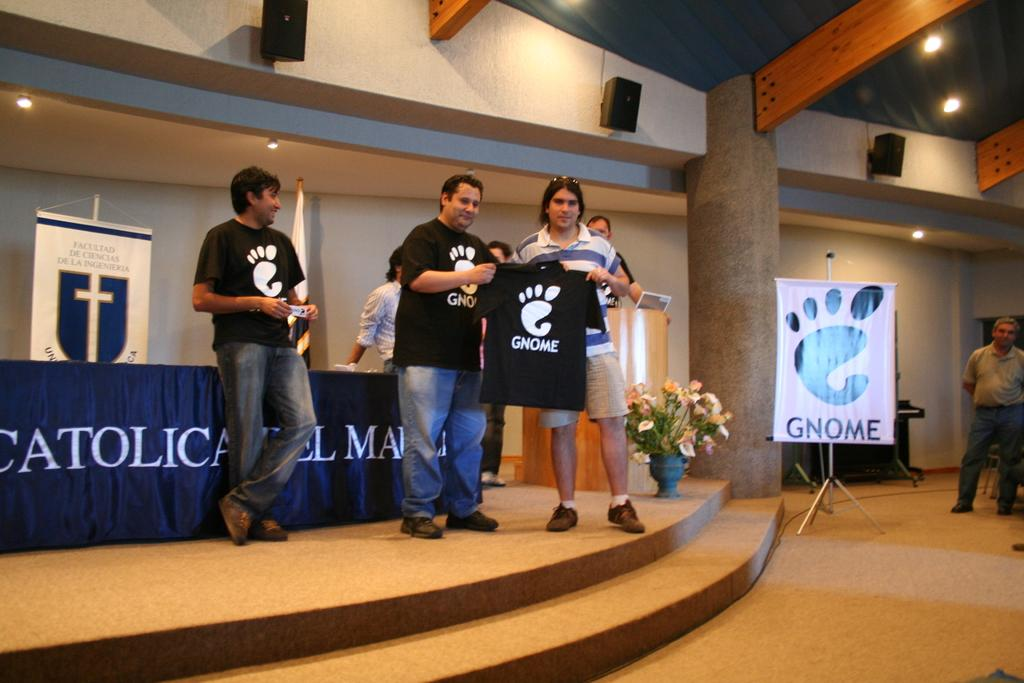<image>
Provide a brief description of the given image. People holding a shirt which says Gnome on it. 